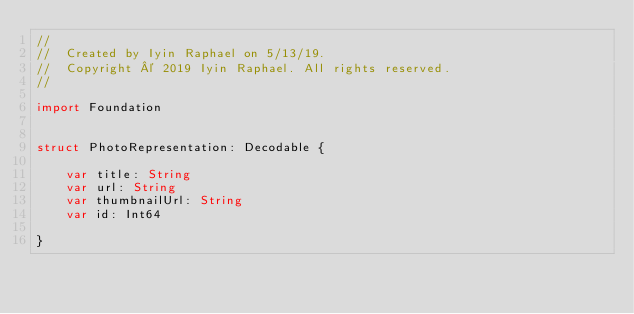<code> <loc_0><loc_0><loc_500><loc_500><_Swift_>//
//  Created by Iyin Raphael on 5/13/19.
//  Copyright © 2019 Iyin Raphael. All rights reserved.
//

import Foundation


struct PhotoRepresentation: Decodable {
    
    var title: String
    var url: String
    var thumbnailUrl: String
    var id: Int64
    
}

</code> 